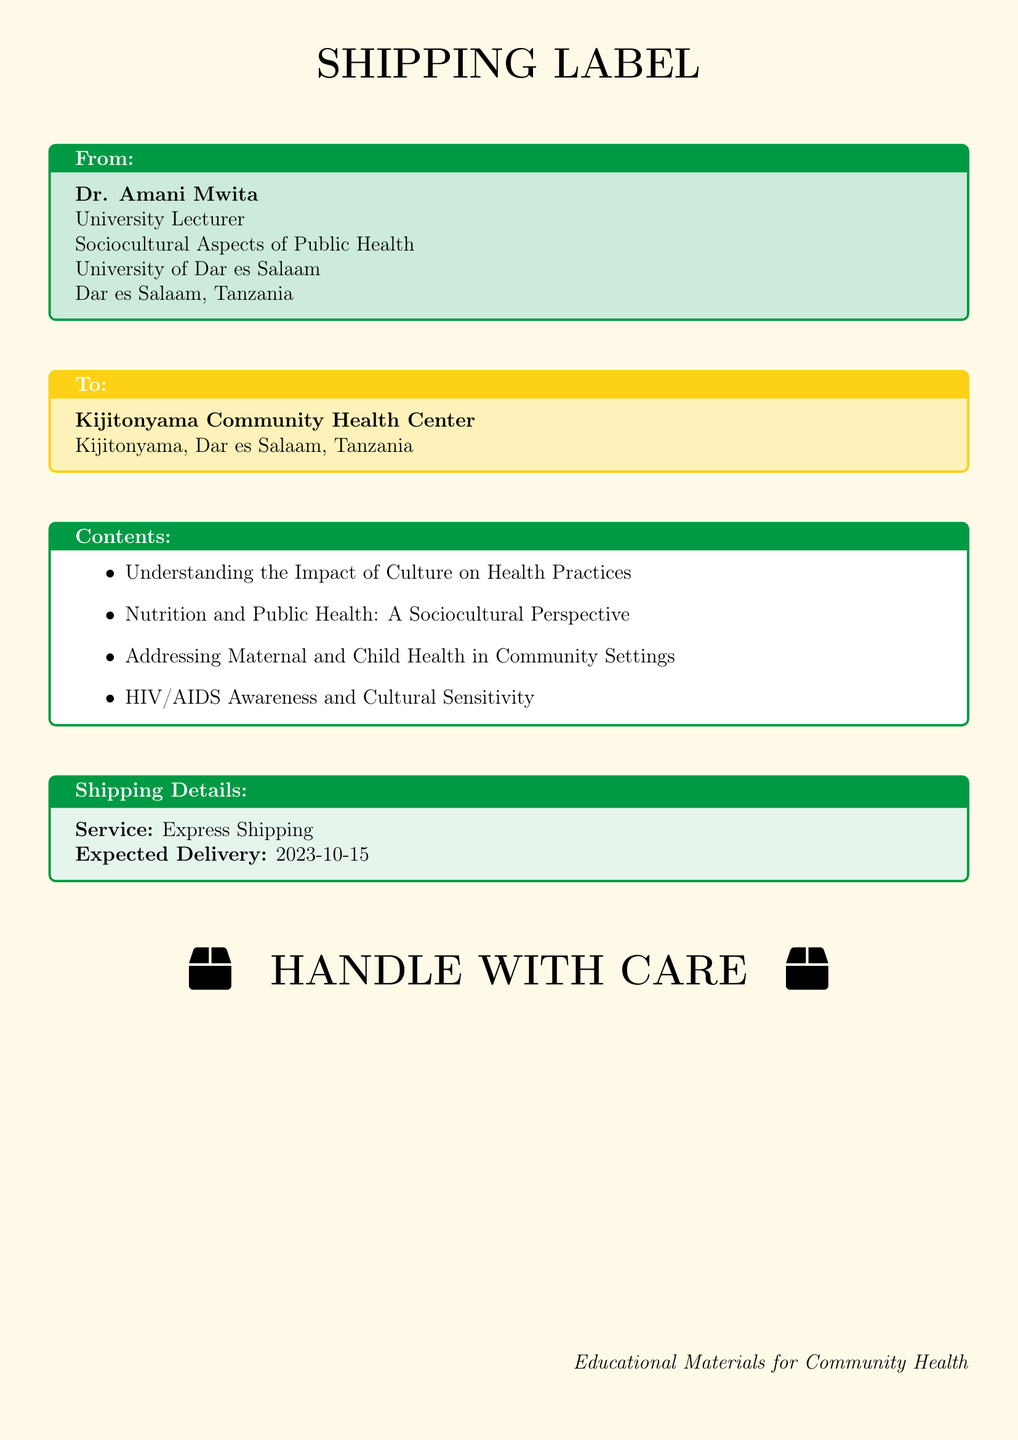what is the sender's name? The sender's name is listed at the top of the document within the "From" section.
Answer: Dr. Amani Mwita what is the recipient's address? The recipient's address can be found in the "To" section of the document.
Answer: Kijitonyama, Dar es Salaam, Tanzania what is the expected delivery date? The expected delivery date is specified in the "Shipping Details" section.
Answer: 2023-10-15 what contents are included in the shipment? The contents can be found listed in the "Contents" section of the document.
Answer: Understanding the Impact of Culture on Health Practices, Nutrition and Public Health: A Sociocultural Perspective, Addressing Maternal and Child Health in Community Settings, HIV/AIDS Awareness and Cultural Sensitivity what shipping service is used? The shipping service is mentioned in the "Shipping Details" section.
Answer: Express Shipping why is it important to handle the package with care? The notation at the bottom of the document emphasizes the importance of careful handling.
Answer: Educational Materials for Community Health which subject areas do the pamphlets cover? The subject areas are all listed in the "Contents" section of the document.
Answer: Public Health, Maternal and Child Health, HIV/AIDS Awareness what color is the shipping label's background? The background color of the label is specified at the beginning of the document.
Answer: Tanzaniayellow!10 who is the intended recipient? The intended recipient is indicated in the "To" section of the document.
Answer: Kijitonyama Community Health Center 